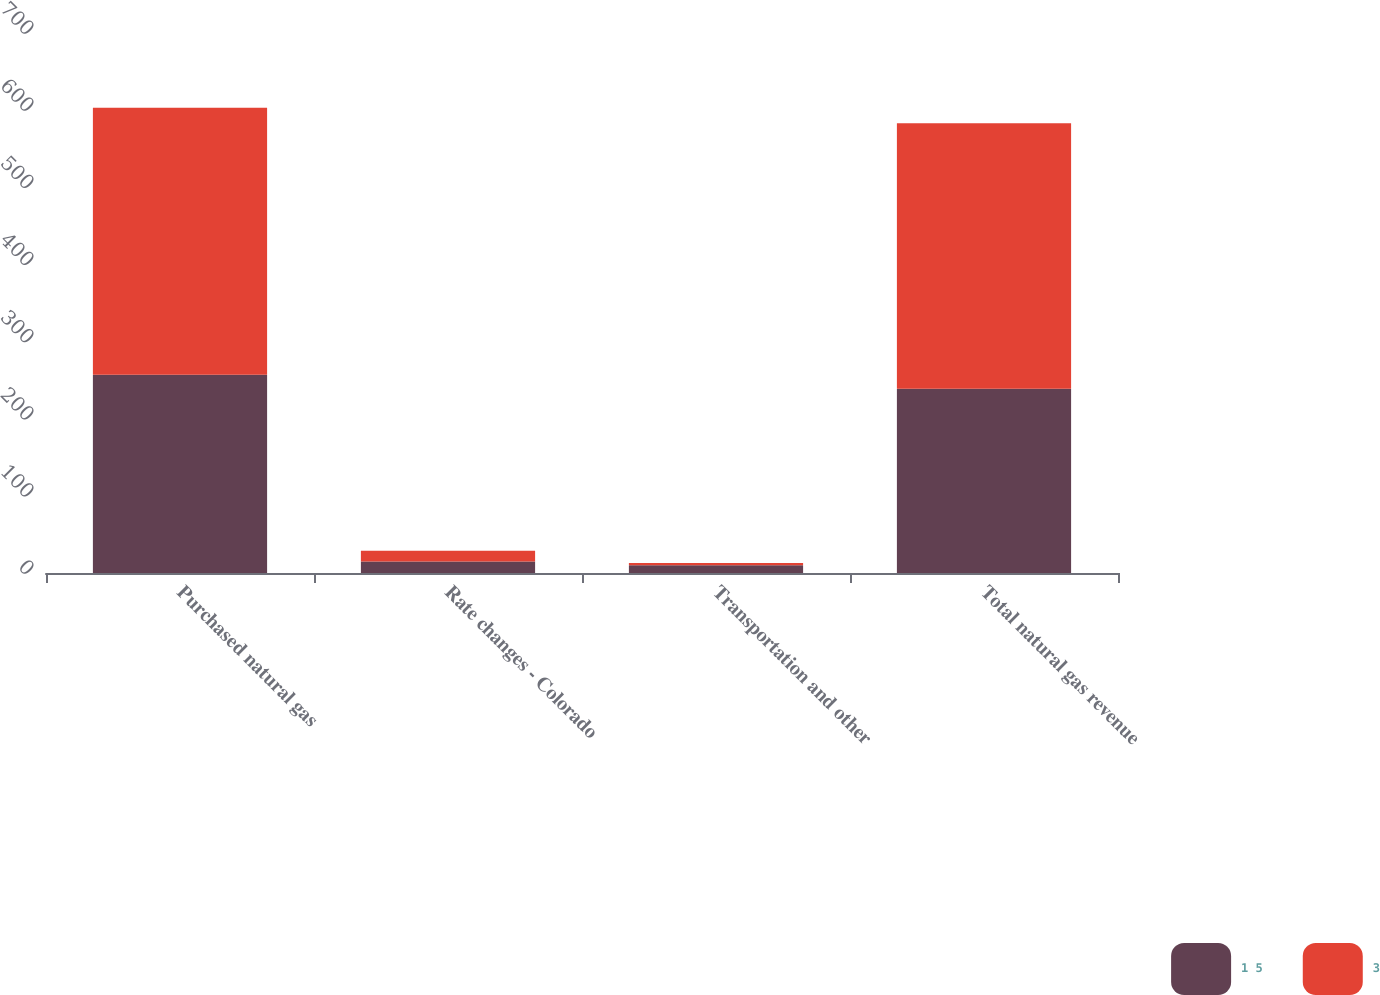<chart> <loc_0><loc_0><loc_500><loc_500><stacked_bar_chart><ecel><fcel>Purchased natural gas<fcel>Rate changes - Colorado<fcel>Transportation and other<fcel>Total natural gas revenue<nl><fcel>1 5<fcel>257<fcel>15<fcel>10<fcel>239<nl><fcel>3<fcel>346<fcel>14<fcel>3<fcel>344<nl></chart> 